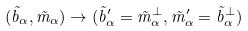<formula> <loc_0><loc_0><loc_500><loc_500>( \vec { b } _ { \alpha } , \vec { m } _ { \alpha } ) \rightarrow ( \vec { b } ^ { \prime } _ { \alpha } = \vec { m } _ { \alpha } ^ { \perp } , \vec { m } ^ { \prime } _ { \alpha } = \vec { b } ^ { \perp } _ { \alpha } )</formula> 